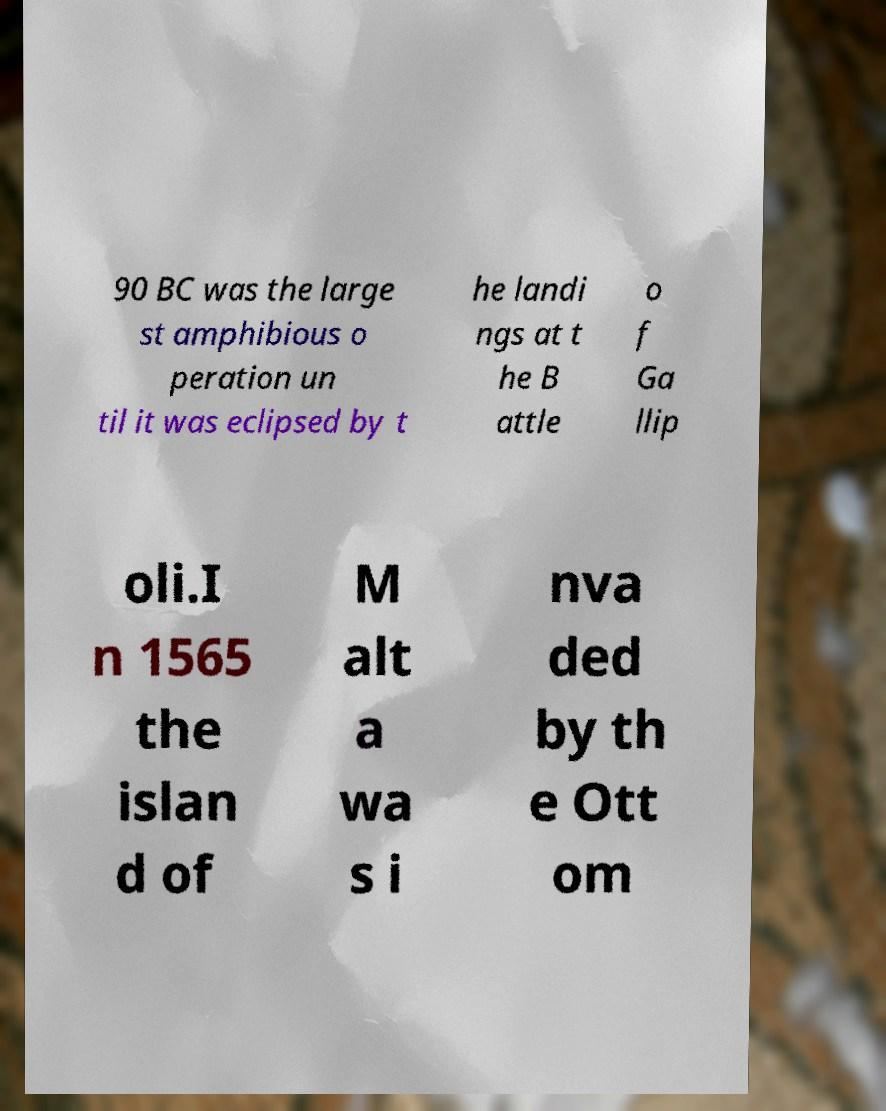Please identify and transcribe the text found in this image. 90 BC was the large st amphibious o peration un til it was eclipsed by t he landi ngs at t he B attle o f Ga llip oli.I n 1565 the islan d of M alt a wa s i nva ded by th e Ott om 